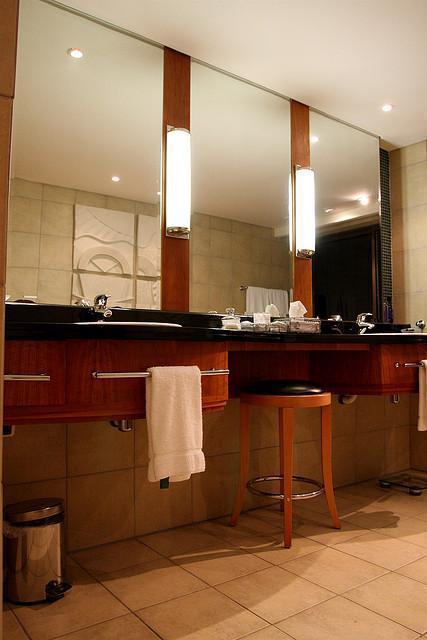How many people can the horse drawn carriage carry?
Give a very brief answer. 0. 